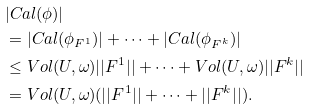Convert formula to latex. <formula><loc_0><loc_0><loc_500><loc_500>& | C a l ( \phi ) | \\ & = | C a l ( \phi _ { F ^ { 1 } } ) | + \cdots + | C a l ( \phi _ { F ^ { k } } ) | \\ & \leq V o l ( U , \omega ) | | F ^ { 1 } | | + \cdots + V o l ( U , \omega ) | | F ^ { k } | | \\ & = V o l ( U , \omega ) ( | | F ^ { 1 } | | + \cdots + | | F ^ { k } | | ) .</formula> 